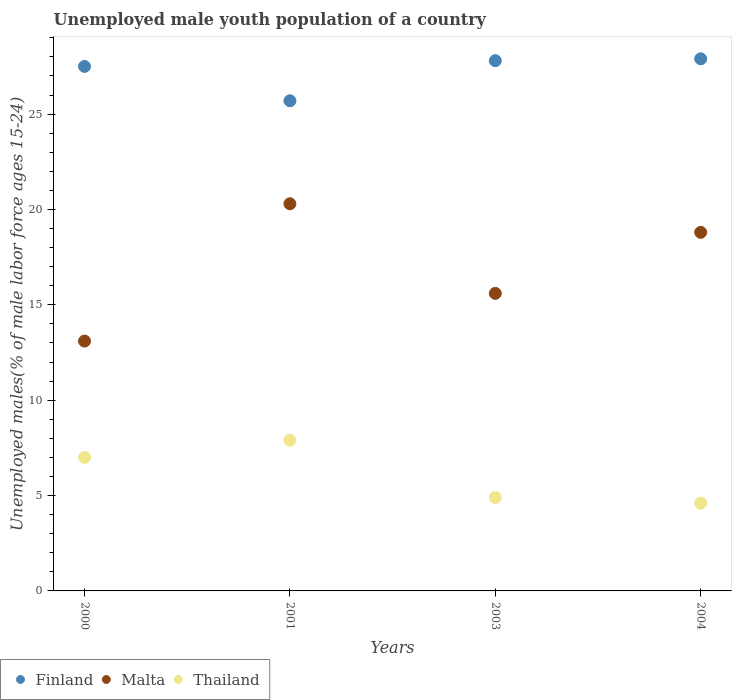Is the number of dotlines equal to the number of legend labels?
Keep it short and to the point. Yes. What is the percentage of unemployed male youth population in Malta in 2004?
Offer a terse response. 18.8. Across all years, what is the maximum percentage of unemployed male youth population in Thailand?
Offer a terse response. 7.9. Across all years, what is the minimum percentage of unemployed male youth population in Thailand?
Give a very brief answer. 4.6. In which year was the percentage of unemployed male youth population in Finland minimum?
Keep it short and to the point. 2001. What is the total percentage of unemployed male youth population in Finland in the graph?
Provide a succinct answer. 108.9. What is the difference between the percentage of unemployed male youth population in Malta in 2003 and that in 2004?
Offer a terse response. -3.2. What is the difference between the percentage of unemployed male youth population in Thailand in 2003 and the percentage of unemployed male youth population in Finland in 2000?
Offer a terse response. -22.6. What is the average percentage of unemployed male youth population in Thailand per year?
Offer a very short reply. 6.1. In the year 2001, what is the difference between the percentage of unemployed male youth population in Finland and percentage of unemployed male youth population in Thailand?
Offer a terse response. 17.8. What is the ratio of the percentage of unemployed male youth population in Malta in 2001 to that in 2004?
Keep it short and to the point. 1.08. What is the difference between the highest and the lowest percentage of unemployed male youth population in Malta?
Provide a succinct answer. 7.2. In how many years, is the percentage of unemployed male youth population in Finland greater than the average percentage of unemployed male youth population in Finland taken over all years?
Your answer should be compact. 3. Is the sum of the percentage of unemployed male youth population in Thailand in 2001 and 2003 greater than the maximum percentage of unemployed male youth population in Finland across all years?
Make the answer very short. No. How many years are there in the graph?
Make the answer very short. 4. What is the difference between two consecutive major ticks on the Y-axis?
Ensure brevity in your answer.  5. Does the graph contain grids?
Make the answer very short. No. How many legend labels are there?
Offer a very short reply. 3. What is the title of the graph?
Give a very brief answer. Unemployed male youth population of a country. What is the label or title of the X-axis?
Your response must be concise. Years. What is the label or title of the Y-axis?
Provide a succinct answer. Unemployed males(% of male labor force ages 15-24). What is the Unemployed males(% of male labor force ages 15-24) of Malta in 2000?
Keep it short and to the point. 13.1. What is the Unemployed males(% of male labor force ages 15-24) in Finland in 2001?
Your answer should be compact. 25.7. What is the Unemployed males(% of male labor force ages 15-24) in Malta in 2001?
Keep it short and to the point. 20.3. What is the Unemployed males(% of male labor force ages 15-24) of Thailand in 2001?
Keep it short and to the point. 7.9. What is the Unemployed males(% of male labor force ages 15-24) in Finland in 2003?
Your answer should be compact. 27.8. What is the Unemployed males(% of male labor force ages 15-24) of Malta in 2003?
Your response must be concise. 15.6. What is the Unemployed males(% of male labor force ages 15-24) in Thailand in 2003?
Provide a succinct answer. 4.9. What is the Unemployed males(% of male labor force ages 15-24) of Finland in 2004?
Your answer should be compact. 27.9. What is the Unemployed males(% of male labor force ages 15-24) of Malta in 2004?
Give a very brief answer. 18.8. What is the Unemployed males(% of male labor force ages 15-24) of Thailand in 2004?
Provide a short and direct response. 4.6. Across all years, what is the maximum Unemployed males(% of male labor force ages 15-24) of Finland?
Provide a succinct answer. 27.9. Across all years, what is the maximum Unemployed males(% of male labor force ages 15-24) in Malta?
Offer a terse response. 20.3. Across all years, what is the maximum Unemployed males(% of male labor force ages 15-24) of Thailand?
Your answer should be compact. 7.9. Across all years, what is the minimum Unemployed males(% of male labor force ages 15-24) of Finland?
Make the answer very short. 25.7. Across all years, what is the minimum Unemployed males(% of male labor force ages 15-24) of Malta?
Ensure brevity in your answer.  13.1. Across all years, what is the minimum Unemployed males(% of male labor force ages 15-24) in Thailand?
Offer a very short reply. 4.6. What is the total Unemployed males(% of male labor force ages 15-24) of Finland in the graph?
Keep it short and to the point. 108.9. What is the total Unemployed males(% of male labor force ages 15-24) of Malta in the graph?
Your answer should be compact. 67.8. What is the total Unemployed males(% of male labor force ages 15-24) in Thailand in the graph?
Offer a very short reply. 24.4. What is the difference between the Unemployed males(% of male labor force ages 15-24) of Finland in 2000 and that in 2001?
Provide a short and direct response. 1.8. What is the difference between the Unemployed males(% of male labor force ages 15-24) in Malta in 2000 and that in 2001?
Make the answer very short. -7.2. What is the difference between the Unemployed males(% of male labor force ages 15-24) in Thailand in 2000 and that in 2001?
Your answer should be compact. -0.9. What is the difference between the Unemployed males(% of male labor force ages 15-24) of Finland in 2000 and that in 2004?
Give a very brief answer. -0.4. What is the difference between the Unemployed males(% of male labor force ages 15-24) in Malta in 2000 and that in 2004?
Make the answer very short. -5.7. What is the difference between the Unemployed males(% of male labor force ages 15-24) of Thailand in 2001 and that in 2003?
Make the answer very short. 3. What is the difference between the Unemployed males(% of male labor force ages 15-24) in Malta in 2001 and that in 2004?
Give a very brief answer. 1.5. What is the difference between the Unemployed males(% of male labor force ages 15-24) of Finland in 2000 and the Unemployed males(% of male labor force ages 15-24) of Malta in 2001?
Ensure brevity in your answer.  7.2. What is the difference between the Unemployed males(% of male labor force ages 15-24) in Finland in 2000 and the Unemployed males(% of male labor force ages 15-24) in Thailand in 2001?
Give a very brief answer. 19.6. What is the difference between the Unemployed males(% of male labor force ages 15-24) of Malta in 2000 and the Unemployed males(% of male labor force ages 15-24) of Thailand in 2001?
Your response must be concise. 5.2. What is the difference between the Unemployed males(% of male labor force ages 15-24) in Finland in 2000 and the Unemployed males(% of male labor force ages 15-24) in Thailand in 2003?
Ensure brevity in your answer.  22.6. What is the difference between the Unemployed males(% of male labor force ages 15-24) of Malta in 2000 and the Unemployed males(% of male labor force ages 15-24) of Thailand in 2003?
Ensure brevity in your answer.  8.2. What is the difference between the Unemployed males(% of male labor force ages 15-24) in Finland in 2000 and the Unemployed males(% of male labor force ages 15-24) in Thailand in 2004?
Your answer should be compact. 22.9. What is the difference between the Unemployed males(% of male labor force ages 15-24) of Finland in 2001 and the Unemployed males(% of male labor force ages 15-24) of Thailand in 2003?
Your answer should be very brief. 20.8. What is the difference between the Unemployed males(% of male labor force ages 15-24) in Finland in 2001 and the Unemployed males(% of male labor force ages 15-24) in Malta in 2004?
Make the answer very short. 6.9. What is the difference between the Unemployed males(% of male labor force ages 15-24) in Finland in 2001 and the Unemployed males(% of male labor force ages 15-24) in Thailand in 2004?
Your answer should be compact. 21.1. What is the difference between the Unemployed males(% of male labor force ages 15-24) in Finland in 2003 and the Unemployed males(% of male labor force ages 15-24) in Thailand in 2004?
Provide a succinct answer. 23.2. What is the difference between the Unemployed males(% of male labor force ages 15-24) of Malta in 2003 and the Unemployed males(% of male labor force ages 15-24) of Thailand in 2004?
Your answer should be very brief. 11. What is the average Unemployed males(% of male labor force ages 15-24) of Finland per year?
Your answer should be compact. 27.23. What is the average Unemployed males(% of male labor force ages 15-24) in Malta per year?
Your response must be concise. 16.95. In the year 2000, what is the difference between the Unemployed males(% of male labor force ages 15-24) in Finland and Unemployed males(% of male labor force ages 15-24) in Thailand?
Your answer should be very brief. 20.5. In the year 2000, what is the difference between the Unemployed males(% of male labor force ages 15-24) in Malta and Unemployed males(% of male labor force ages 15-24) in Thailand?
Ensure brevity in your answer.  6.1. In the year 2001, what is the difference between the Unemployed males(% of male labor force ages 15-24) in Malta and Unemployed males(% of male labor force ages 15-24) in Thailand?
Give a very brief answer. 12.4. In the year 2003, what is the difference between the Unemployed males(% of male labor force ages 15-24) of Finland and Unemployed males(% of male labor force ages 15-24) of Malta?
Make the answer very short. 12.2. In the year 2003, what is the difference between the Unemployed males(% of male labor force ages 15-24) of Finland and Unemployed males(% of male labor force ages 15-24) of Thailand?
Your response must be concise. 22.9. In the year 2004, what is the difference between the Unemployed males(% of male labor force ages 15-24) of Finland and Unemployed males(% of male labor force ages 15-24) of Thailand?
Make the answer very short. 23.3. What is the ratio of the Unemployed males(% of male labor force ages 15-24) in Finland in 2000 to that in 2001?
Offer a very short reply. 1.07. What is the ratio of the Unemployed males(% of male labor force ages 15-24) of Malta in 2000 to that in 2001?
Provide a succinct answer. 0.65. What is the ratio of the Unemployed males(% of male labor force ages 15-24) in Thailand in 2000 to that in 2001?
Keep it short and to the point. 0.89. What is the ratio of the Unemployed males(% of male labor force ages 15-24) of Malta in 2000 to that in 2003?
Your response must be concise. 0.84. What is the ratio of the Unemployed males(% of male labor force ages 15-24) of Thailand in 2000 to that in 2003?
Your answer should be very brief. 1.43. What is the ratio of the Unemployed males(% of male labor force ages 15-24) of Finland in 2000 to that in 2004?
Offer a terse response. 0.99. What is the ratio of the Unemployed males(% of male labor force ages 15-24) of Malta in 2000 to that in 2004?
Your answer should be very brief. 0.7. What is the ratio of the Unemployed males(% of male labor force ages 15-24) of Thailand in 2000 to that in 2004?
Make the answer very short. 1.52. What is the ratio of the Unemployed males(% of male labor force ages 15-24) in Finland in 2001 to that in 2003?
Your answer should be compact. 0.92. What is the ratio of the Unemployed males(% of male labor force ages 15-24) in Malta in 2001 to that in 2003?
Your answer should be compact. 1.3. What is the ratio of the Unemployed males(% of male labor force ages 15-24) of Thailand in 2001 to that in 2003?
Provide a succinct answer. 1.61. What is the ratio of the Unemployed males(% of male labor force ages 15-24) in Finland in 2001 to that in 2004?
Ensure brevity in your answer.  0.92. What is the ratio of the Unemployed males(% of male labor force ages 15-24) of Malta in 2001 to that in 2004?
Offer a terse response. 1.08. What is the ratio of the Unemployed males(% of male labor force ages 15-24) of Thailand in 2001 to that in 2004?
Provide a short and direct response. 1.72. What is the ratio of the Unemployed males(% of male labor force ages 15-24) of Malta in 2003 to that in 2004?
Ensure brevity in your answer.  0.83. What is the ratio of the Unemployed males(% of male labor force ages 15-24) in Thailand in 2003 to that in 2004?
Your response must be concise. 1.07. What is the difference between the highest and the second highest Unemployed males(% of male labor force ages 15-24) of Malta?
Your answer should be compact. 1.5. What is the difference between the highest and the second highest Unemployed males(% of male labor force ages 15-24) in Thailand?
Give a very brief answer. 0.9. What is the difference between the highest and the lowest Unemployed males(% of male labor force ages 15-24) in Finland?
Your answer should be compact. 2.2. What is the difference between the highest and the lowest Unemployed males(% of male labor force ages 15-24) of Malta?
Give a very brief answer. 7.2. 